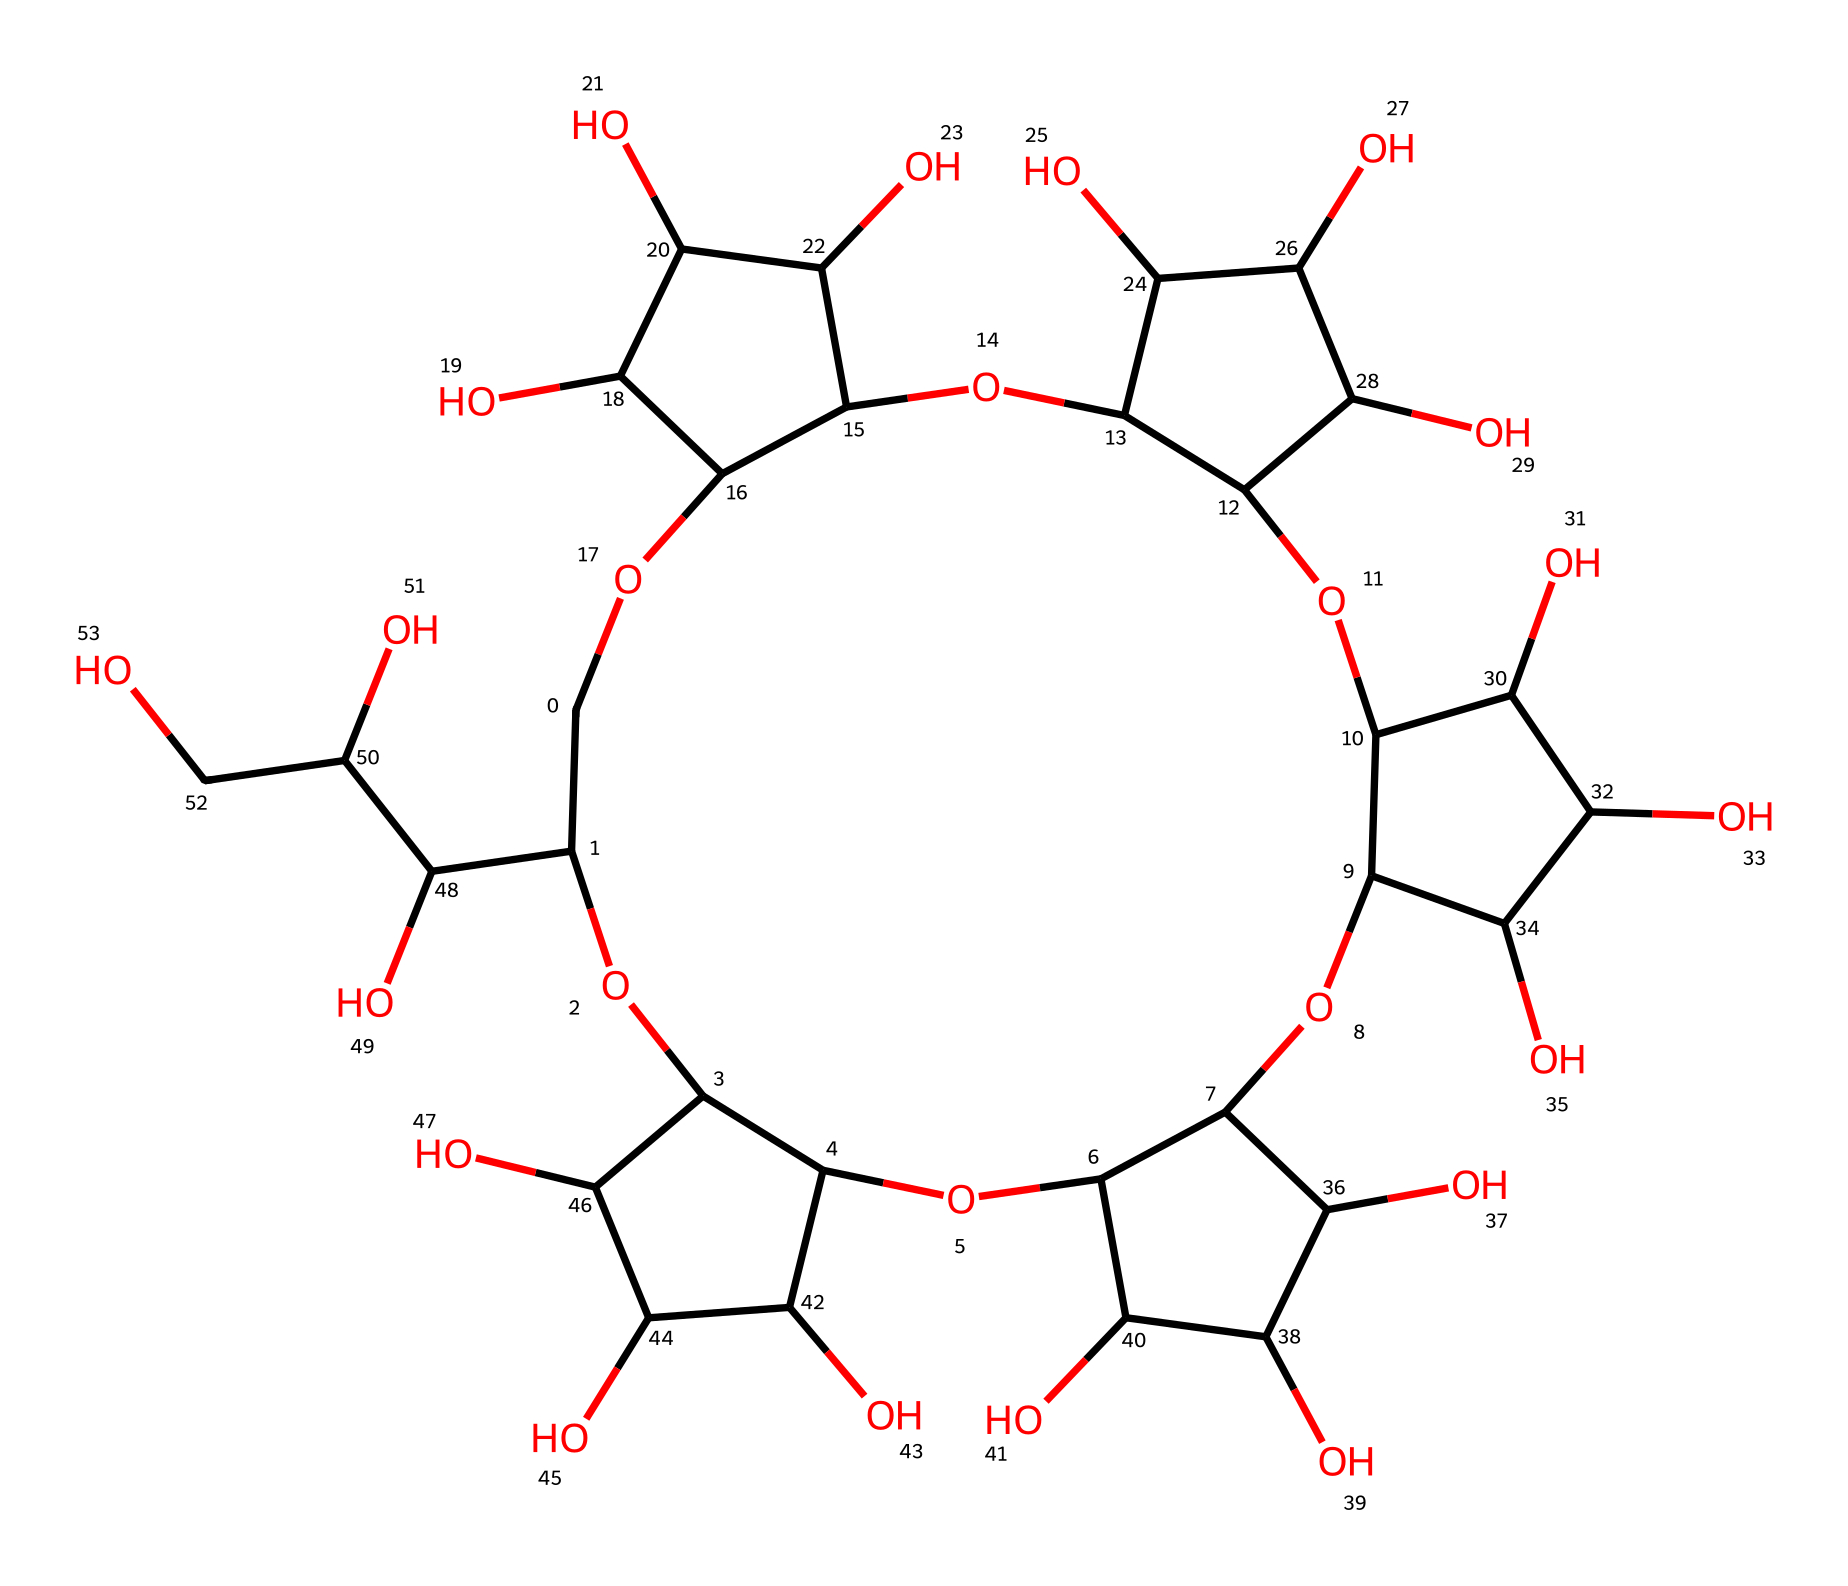What is the molecular formula of the cyclodextrin represented? To derive the molecular formula from the SMILES representation, you can count the number of each type of atom in the structure. The SMILES indicates multiple hydroxyl (–OH) groups, and the detailed structure suggests it's derived from glucose units. Each cyclodextrin is typically composed of glucose monomers. For this particular representation, it contains 6 glucose units with no additional elements, leading to the molecular formula C36H62O30.
Answer: C36H62O30 How many glucose units are present in this cyclodextrin? Analyzing the structural representation, cyclodextrins are cyclic oligomers of glucose. Each glucose contributes one ring structure, and you can count the number of interconnected glucose units in the cyclodextrin structure to find that there are 6 interconnected glucose units.
Answer: 6 What type of carbohydrate is cyclodextrin classified as? Cyclodextrin consists of cyclic oligomers formed from glucose units, specifically categorized as oligosaccharides. Oligosaccharides are carbohydrates made up of a small number of monosaccharides (in this case, glucose), typically between 3 to 10 units. Hence, cyclodextrin fits this classification of carbohydrate.
Answer: oligosaccharide Does cyclodextrin have any functional groups? By examining the SMILES and structure, the presence of multiple hydroxyl (–OH) groups indicates that cyclodextrin contains functional groups. Hydroxyl groups are responsible for many of the carbohydrate's properties, making it soluble in water and significant for drug delivery systems.
Answer: hydroxyl groups How does the structure of cyclodextrin benefit drug delivery? Cyclodextrin’s unique hollow structure allows it to form complexes with drug molecules, improving solubility and stability. This characteristic of encapsulating the drug within its cyclic cavity enhances bioavailability, making it a valuable excipient in pharmaceutical formulations.
Answer: enhances bioavailability 